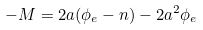<formula> <loc_0><loc_0><loc_500><loc_500>- M = 2 a ( { \phi _ { e } } - n ) - 2 a ^ { 2 } { \phi _ { e } }</formula> 